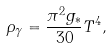Convert formula to latex. <formula><loc_0><loc_0><loc_500><loc_500>\rho _ { \gamma } = \frac { \pi ^ { 2 } g _ { * } } { 3 0 } T ^ { 4 } ,</formula> 